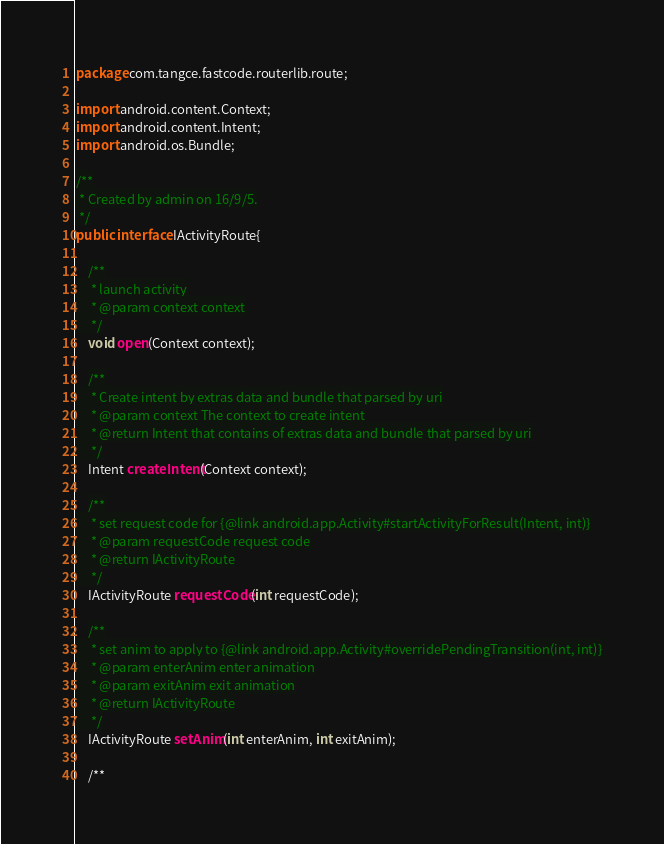<code> <loc_0><loc_0><loc_500><loc_500><_Java_>package com.tangce.fastcode.routerlib.route;

import android.content.Context;
import android.content.Intent;
import android.os.Bundle;

/**
 * Created by admin on 16/9/5.
 */
public interface IActivityRoute{

    /**
     * launch activity
     * @param context context
     */
    void open(Context context);

    /**
     * Create intent by extras data and bundle that parsed by uri
     * @param context The context to create intent
     * @return Intent that contains of extras data and bundle that parsed by uri
     */
    Intent createIntent(Context context);

    /**
     * set request code for {@link android.app.Activity#startActivityForResult(Intent, int)}
     * @param requestCode request code
     * @return IActivityRoute
     */
    IActivityRoute requestCode(int requestCode);

    /**
     * set anim to apply to {@link android.app.Activity#overridePendingTransition(int, int)}
     * @param enterAnim enter animation
     * @param exitAnim exit animation
     * @return IActivityRoute
     */
    IActivityRoute setAnim(int enterAnim, int exitAnim);

    /**</code> 